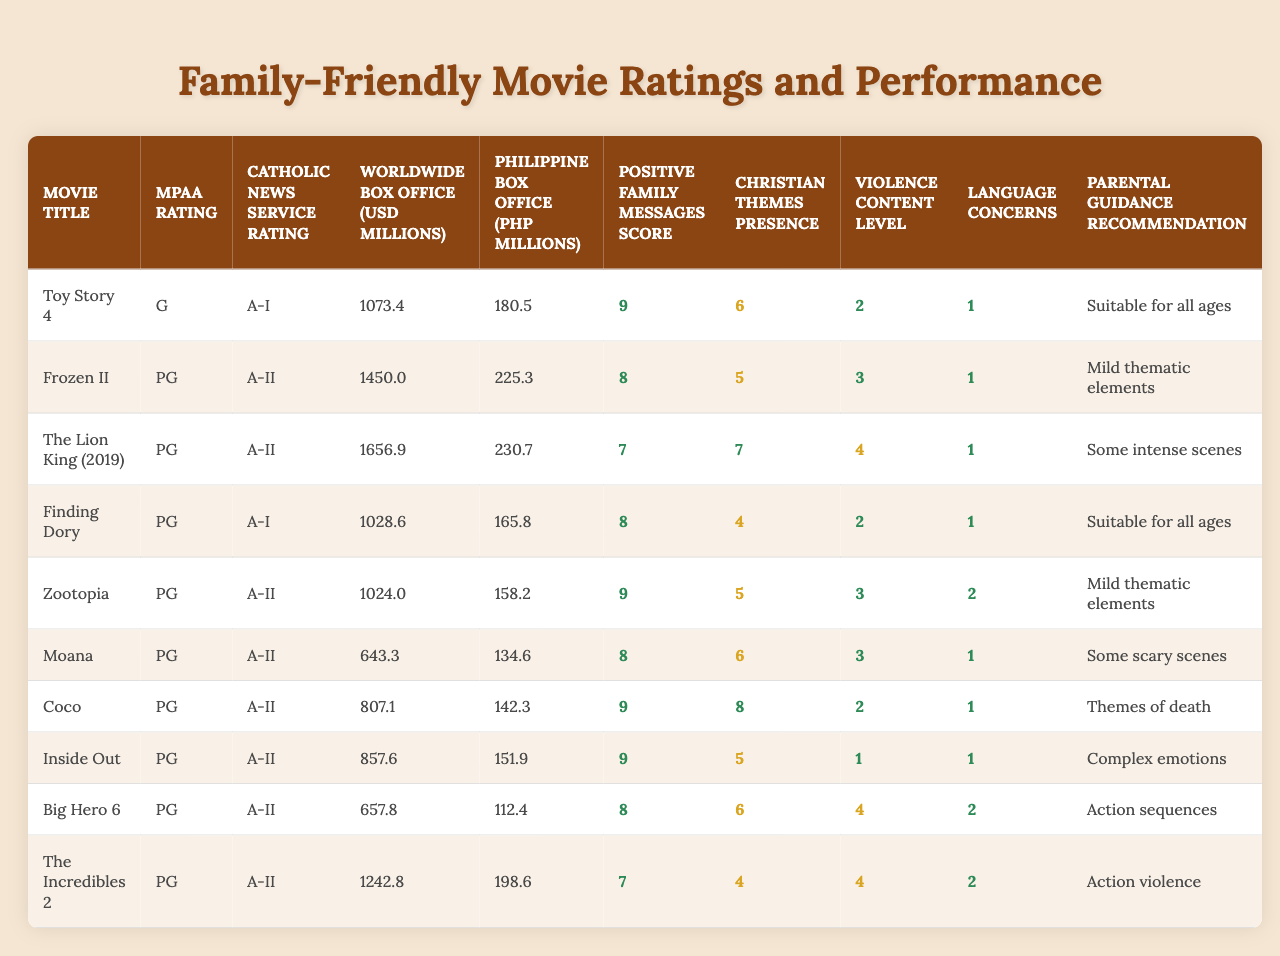What is the highest grossing movie on the list? The table shows the worldwide box office values for each movie. By examining the "Worldwide Box Office (USD millions)" column, we can see that "The Lion King (2019)" has the highest value at 1656.9 million USD.
Answer: The Lion King (2019) How many movies received a Catholic News Service Rating of A-II? We can count the entries in the "Catholic News Service Rating" column. The movies with a rating of A-II are: "Frozen II," "The Lion King (2019)," "Zootopia," "Moana," "Coco," "Inside Out," and "The Incredibles 2." This totals to six movies.
Answer: 6 What is the average Positive Family Messages Score of all the movies? To get the average, we sum all the scores (9 + 8 + 7 + 8 + 9 + 8 + 9 + 9 + 8 + 7 = 81) and divide by the number of movies (10), so the average is 81/10 = 8.1.
Answer: 8.1 Which movie has the lowest Violence Content Level? In the "Violence Content Level" column, we can see that "Inside Out" has the lowest level, which is 1.
Answer: Inside Out Is "Finding Dory" suitable for children of all ages? We check the "Parental Guidance Recommendation" column for "Finding Dory." It states "Suitable for all ages," indicating it is appropriate for children of all ages.
Answer: Yes Which movie had the highest box office revenue in the Philippines? Looking at the "Philippine Box Office (PHP millions)" column, "The Lion King (2019)" has the highest revenue at 230.7 million PHP.
Answer: The Lion King (2019) Do most movies on this list contain Christian themes? We would assess the scores in the "Christian Themes Presence" column. Most of the scores are below 5, specifically, only "Coco" received a score of 8, suggesting that Christian themes are not dominantly present in most films.
Answer: No What is the difference in worldwide box office revenue between "Toy Story 4" and "Moana"? We subtract the worldwide box office of "Moana" (643.3 million USD) from "Toy Story 4" (1073.4 million USD): 1073.4 - 643.3 = 430.1 million USD.
Answer: 430.1 million USD How many movies have a Positive Family Messages Score of 8 or higher? We can look through the "Positive Family Messages Score" column and count the scores of 8 or higher: "Toy Story 4," "Frozen II," "Finding Dory," "Zootopia," "Moana," "Coco," "Inside Out," and "The Incredibles 2," which gives us a total of 8 movies.
Answer: 8 What percentage of movies on the list have an MPAA rating of PG? Out of the 10 movies listed, 9 have a PG rating, so the percentage is (9/10)*100 = 90%.
Answer: 90% 